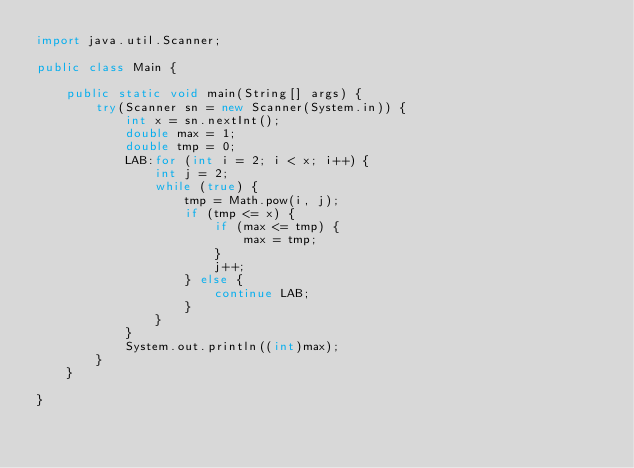<code> <loc_0><loc_0><loc_500><loc_500><_Java_>import java.util.Scanner;

public class Main {

	public static void main(String[] args) {
		try(Scanner sn = new Scanner(System.in)) {
			int x = sn.nextInt();
			double max = 1;
			double tmp = 0;
			LAB:for (int i = 2; i < x; i++) {
				int j = 2;
				while (true) {
					tmp = Math.pow(i, j);
					if (tmp <= x) {
						if (max <= tmp) {
							max = tmp;
						}
						j++;
					} else {
						continue LAB;
					}
				}
			}
			System.out.println((int)max);
		}
	}

}
</code> 